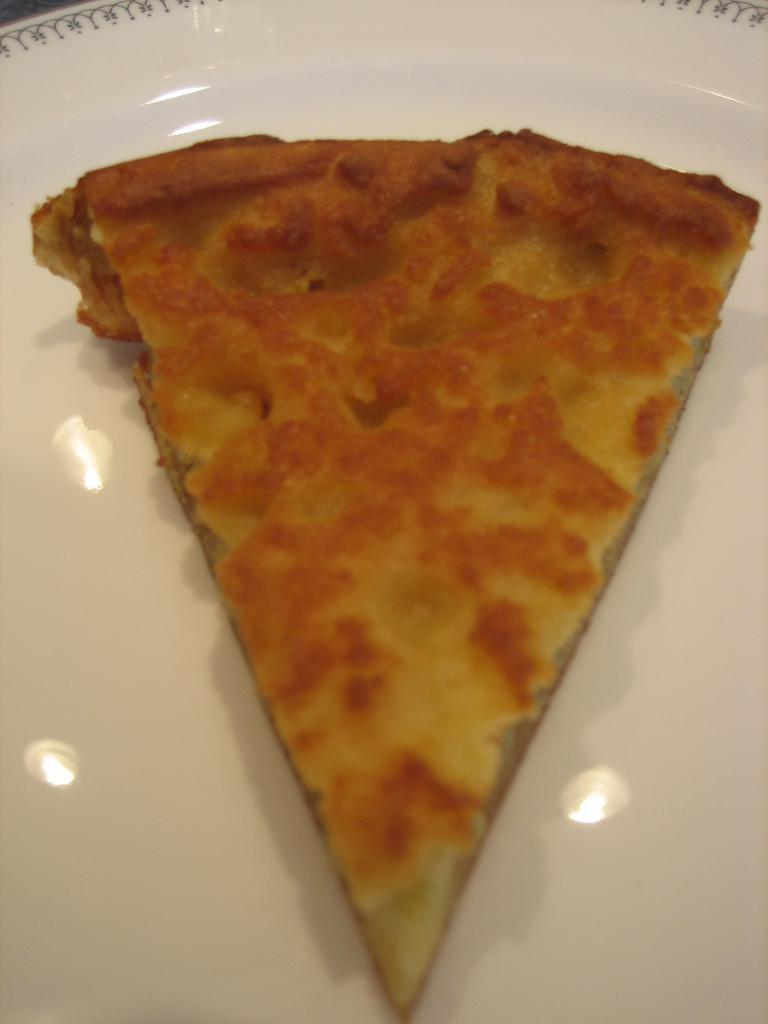What is present on the plate in the image? There is food on a white plate in the image. How can you describe the appearance of the plate? The plate is white, and light reflections are visible on it. How does the food contribute to pollution in the image? The image does not show any indication of pollution, and the food itself does not contribute to pollution. 